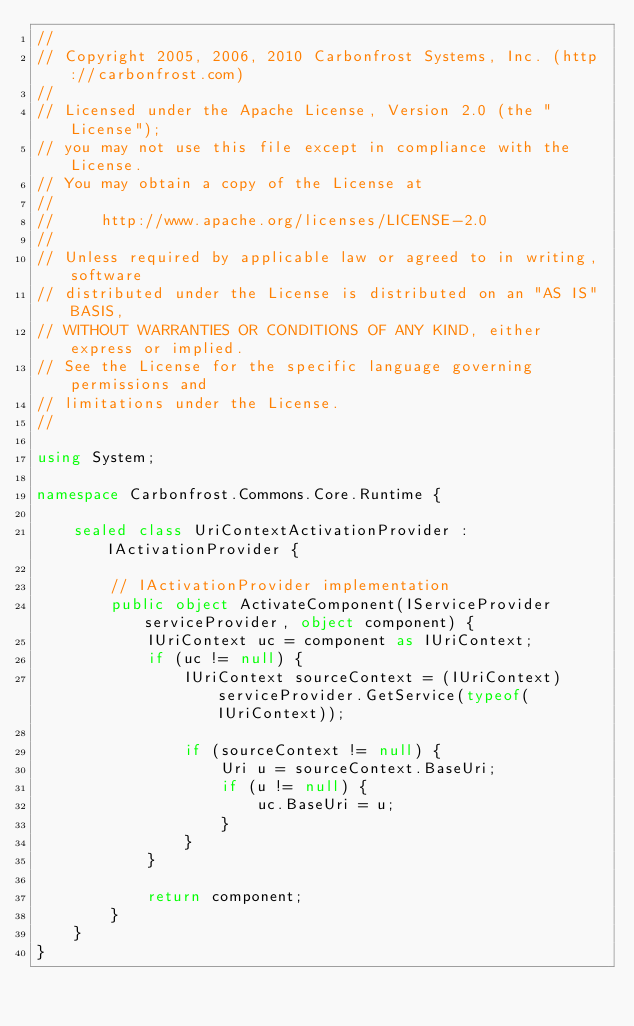Convert code to text. <code><loc_0><loc_0><loc_500><loc_500><_C#_>//
// Copyright 2005, 2006, 2010 Carbonfrost Systems, Inc. (http://carbonfrost.com)
//
// Licensed under the Apache License, Version 2.0 (the "License");
// you may not use this file except in compliance with the License.
// You may obtain a copy of the License at
//
//     http://www.apache.org/licenses/LICENSE-2.0
//
// Unless required by applicable law or agreed to in writing, software
// distributed under the License is distributed on an "AS IS" BASIS,
// WITHOUT WARRANTIES OR CONDITIONS OF ANY KIND, either express or implied.
// See the License for the specific language governing permissions and
// limitations under the License.
//

using System;

namespace Carbonfrost.Commons.Core.Runtime {

    sealed class UriContextActivationProvider : IActivationProvider {

        // IActivationProvider implementation
        public object ActivateComponent(IServiceProvider serviceProvider, object component) {
            IUriContext uc = component as IUriContext;
            if (uc != null) {
                IUriContext sourceContext = (IUriContext) serviceProvider.GetService(typeof(IUriContext));

                if (sourceContext != null) {
                    Uri u = sourceContext.BaseUri;
                    if (u != null) {
                        uc.BaseUri = u;
                    }
                }
            }

            return component;
        }
    }
}
</code> 